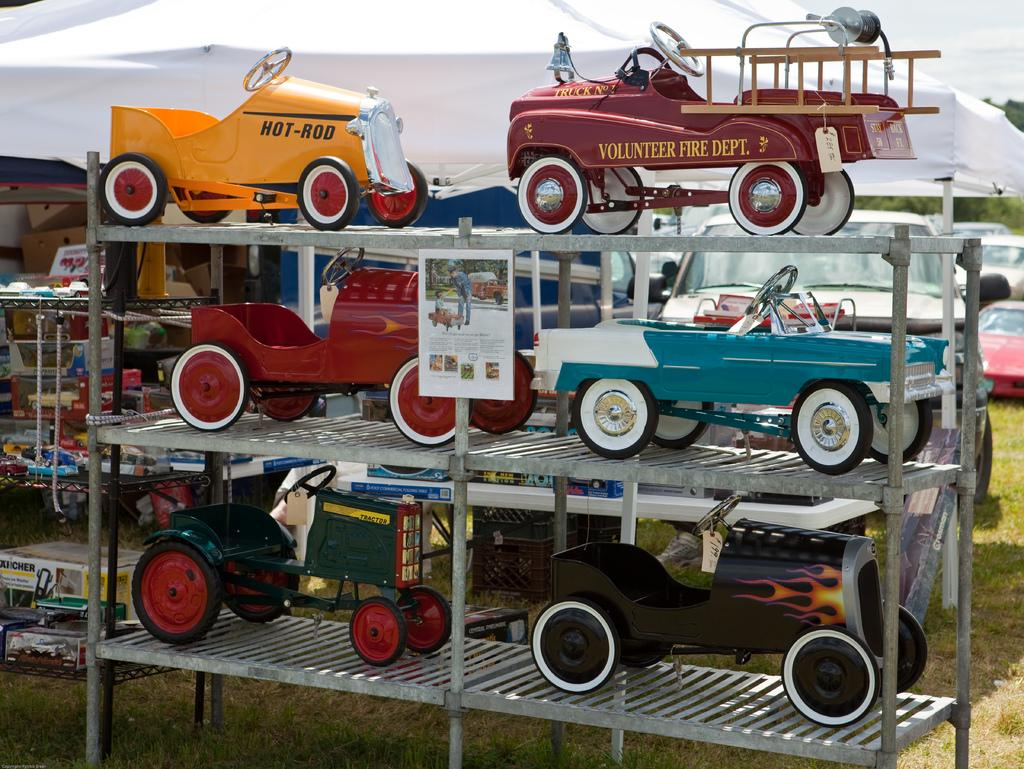What type of toys are on the rack in the image? There are toy cars on a rack in the image. What other toys can be seen in the background? There are other toys visible in the background. What else is visible in the background besides toys? Cars and trees are visible in the background. What is located at the top of the image? There is a tent on the top of the image. What type of honey can be seen dripping from the toy cars in the image? There is no honey present in the image; it features toy cars on a rack and other toys and objects in the background. What shape is the bird in the image? There is no bird present in the image. 